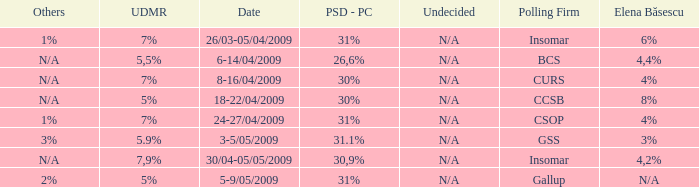Write the full table. {'header': ['Others', 'UDMR', 'Date', 'PSD - PC', 'Undecided', 'Polling Firm', 'Elena Băsescu'], 'rows': [['1%', '7%', '26/03-05/04/2009', '31%', 'N/A', 'Insomar', '6%'], ['N/A', '5,5%', '6-14/04/2009', '26,6%', 'N/A', 'BCS', '4,4%'], ['N/A', '7%', '8-16/04/2009', '30%', 'N/A', 'CURS', '4%'], ['N/A', '5%', '18-22/04/2009', '30%', 'N/A', 'CCSB', '8%'], ['1%', '7%', '24-27/04/2009', '31%', 'N/A', 'CSOP', '4%'], ['3%', '5.9%', '3-5/05/2009', '31.1%', 'N/A', 'GSS', '3%'], ['N/A', '7,9%', '30/04-05/05/2009', '30,9%', 'N/A', 'Insomar', '4,2%'], ['2%', '5%', '5-9/05/2009', '31%', 'N/A', 'Gallup', 'N/A']]} What was the UDMR for 18-22/04/2009? 5%. 